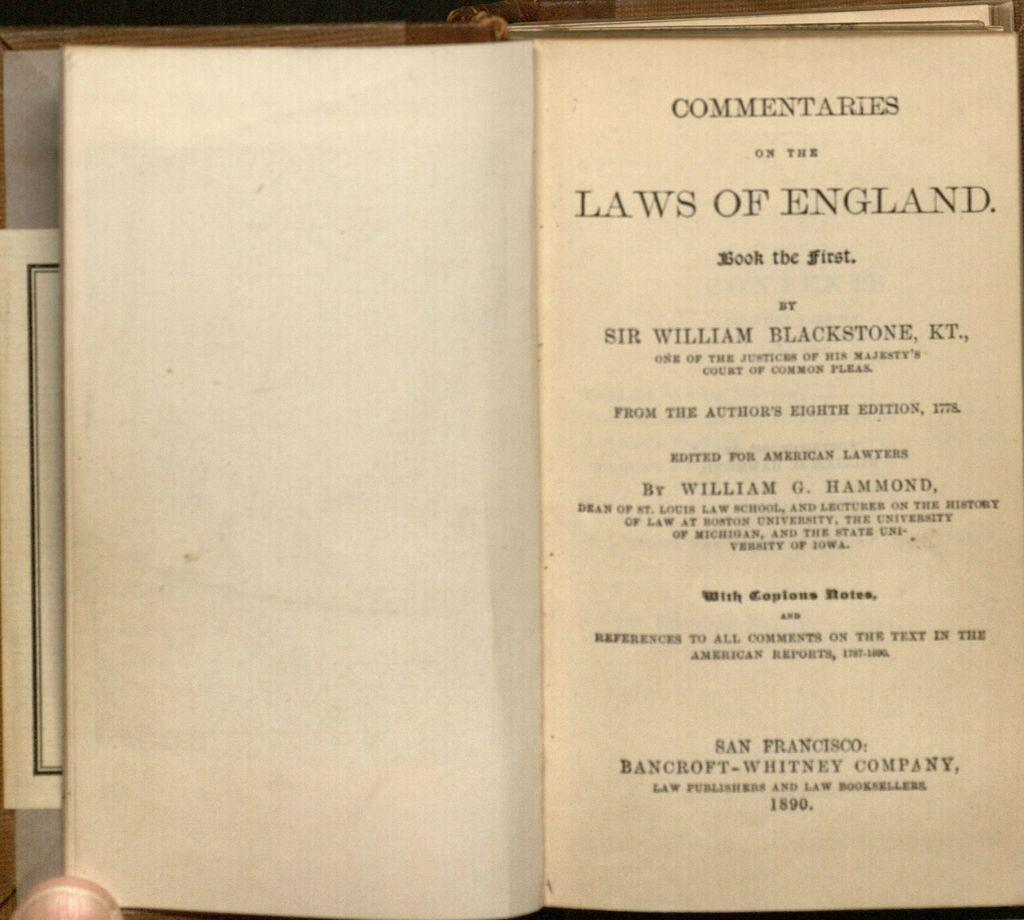<image>
Give a short and clear explanation of the subsequent image. Sir Williaim Blackstone KT., is one of the Justices of His Majesty's Court of Common Pleas. 